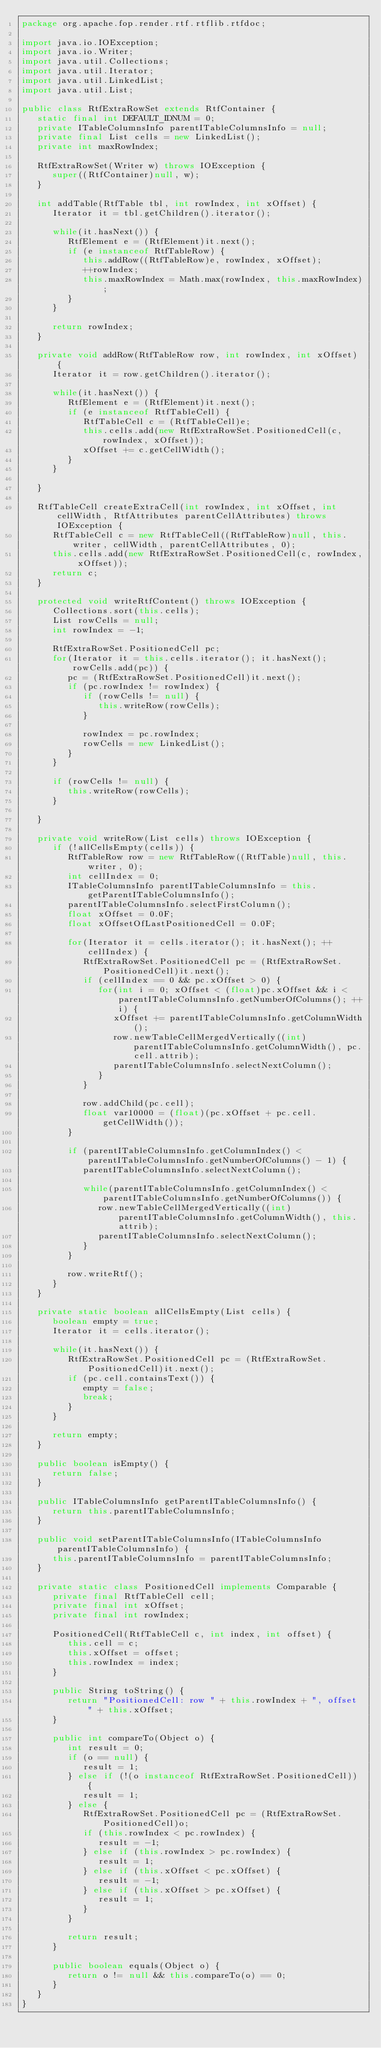<code> <loc_0><loc_0><loc_500><loc_500><_Java_>package org.apache.fop.render.rtf.rtflib.rtfdoc;

import java.io.IOException;
import java.io.Writer;
import java.util.Collections;
import java.util.Iterator;
import java.util.LinkedList;
import java.util.List;

public class RtfExtraRowSet extends RtfContainer {
   static final int DEFAULT_IDNUM = 0;
   private ITableColumnsInfo parentITableColumnsInfo = null;
   private final List cells = new LinkedList();
   private int maxRowIndex;

   RtfExtraRowSet(Writer w) throws IOException {
      super((RtfContainer)null, w);
   }

   int addTable(RtfTable tbl, int rowIndex, int xOffset) {
      Iterator it = tbl.getChildren().iterator();

      while(it.hasNext()) {
         RtfElement e = (RtfElement)it.next();
         if (e instanceof RtfTableRow) {
            this.addRow((RtfTableRow)e, rowIndex, xOffset);
            ++rowIndex;
            this.maxRowIndex = Math.max(rowIndex, this.maxRowIndex);
         }
      }

      return rowIndex;
   }

   private void addRow(RtfTableRow row, int rowIndex, int xOffset) {
      Iterator it = row.getChildren().iterator();

      while(it.hasNext()) {
         RtfElement e = (RtfElement)it.next();
         if (e instanceof RtfTableCell) {
            RtfTableCell c = (RtfTableCell)e;
            this.cells.add(new RtfExtraRowSet.PositionedCell(c, rowIndex, xOffset));
            xOffset += c.getCellWidth();
         }
      }

   }

   RtfTableCell createExtraCell(int rowIndex, int xOffset, int cellWidth, RtfAttributes parentCellAttributes) throws IOException {
      RtfTableCell c = new RtfTableCell((RtfTableRow)null, this.writer, cellWidth, parentCellAttributes, 0);
      this.cells.add(new RtfExtraRowSet.PositionedCell(c, rowIndex, xOffset));
      return c;
   }

   protected void writeRtfContent() throws IOException {
      Collections.sort(this.cells);
      List rowCells = null;
      int rowIndex = -1;

      RtfExtraRowSet.PositionedCell pc;
      for(Iterator it = this.cells.iterator(); it.hasNext(); rowCells.add(pc)) {
         pc = (RtfExtraRowSet.PositionedCell)it.next();
         if (pc.rowIndex != rowIndex) {
            if (rowCells != null) {
               this.writeRow(rowCells);
            }

            rowIndex = pc.rowIndex;
            rowCells = new LinkedList();
         }
      }

      if (rowCells != null) {
         this.writeRow(rowCells);
      }

   }

   private void writeRow(List cells) throws IOException {
      if (!allCellsEmpty(cells)) {
         RtfTableRow row = new RtfTableRow((RtfTable)null, this.writer, 0);
         int cellIndex = 0;
         ITableColumnsInfo parentITableColumnsInfo = this.getParentITableColumnsInfo();
         parentITableColumnsInfo.selectFirstColumn();
         float xOffset = 0.0F;
         float xOffsetOfLastPositionedCell = 0.0F;

         for(Iterator it = cells.iterator(); it.hasNext(); ++cellIndex) {
            RtfExtraRowSet.PositionedCell pc = (RtfExtraRowSet.PositionedCell)it.next();
            if (cellIndex == 0 && pc.xOffset > 0) {
               for(int i = 0; xOffset < (float)pc.xOffset && i < parentITableColumnsInfo.getNumberOfColumns(); ++i) {
                  xOffset += parentITableColumnsInfo.getColumnWidth();
                  row.newTableCellMergedVertically((int)parentITableColumnsInfo.getColumnWidth(), pc.cell.attrib);
                  parentITableColumnsInfo.selectNextColumn();
               }
            }

            row.addChild(pc.cell);
            float var10000 = (float)(pc.xOffset + pc.cell.getCellWidth());
         }

         if (parentITableColumnsInfo.getColumnIndex() < parentITableColumnsInfo.getNumberOfColumns() - 1) {
            parentITableColumnsInfo.selectNextColumn();

            while(parentITableColumnsInfo.getColumnIndex() < parentITableColumnsInfo.getNumberOfColumns()) {
               row.newTableCellMergedVertically((int)parentITableColumnsInfo.getColumnWidth(), this.attrib);
               parentITableColumnsInfo.selectNextColumn();
            }
         }

         row.writeRtf();
      }
   }

   private static boolean allCellsEmpty(List cells) {
      boolean empty = true;
      Iterator it = cells.iterator();

      while(it.hasNext()) {
         RtfExtraRowSet.PositionedCell pc = (RtfExtraRowSet.PositionedCell)it.next();
         if (pc.cell.containsText()) {
            empty = false;
            break;
         }
      }

      return empty;
   }

   public boolean isEmpty() {
      return false;
   }

   public ITableColumnsInfo getParentITableColumnsInfo() {
      return this.parentITableColumnsInfo;
   }

   public void setParentITableColumnsInfo(ITableColumnsInfo parentITableColumnsInfo) {
      this.parentITableColumnsInfo = parentITableColumnsInfo;
   }

   private static class PositionedCell implements Comparable {
      private final RtfTableCell cell;
      private final int xOffset;
      private final int rowIndex;

      PositionedCell(RtfTableCell c, int index, int offset) {
         this.cell = c;
         this.xOffset = offset;
         this.rowIndex = index;
      }

      public String toString() {
         return "PositionedCell: row " + this.rowIndex + ", offset " + this.xOffset;
      }

      public int compareTo(Object o) {
         int result = 0;
         if (o == null) {
            result = 1;
         } else if (!(o instanceof RtfExtraRowSet.PositionedCell)) {
            result = 1;
         } else {
            RtfExtraRowSet.PositionedCell pc = (RtfExtraRowSet.PositionedCell)o;
            if (this.rowIndex < pc.rowIndex) {
               result = -1;
            } else if (this.rowIndex > pc.rowIndex) {
               result = 1;
            } else if (this.xOffset < pc.xOffset) {
               result = -1;
            } else if (this.xOffset > pc.xOffset) {
               result = 1;
            }
         }

         return result;
      }

      public boolean equals(Object o) {
         return o != null && this.compareTo(o) == 0;
      }
   }
}
</code> 